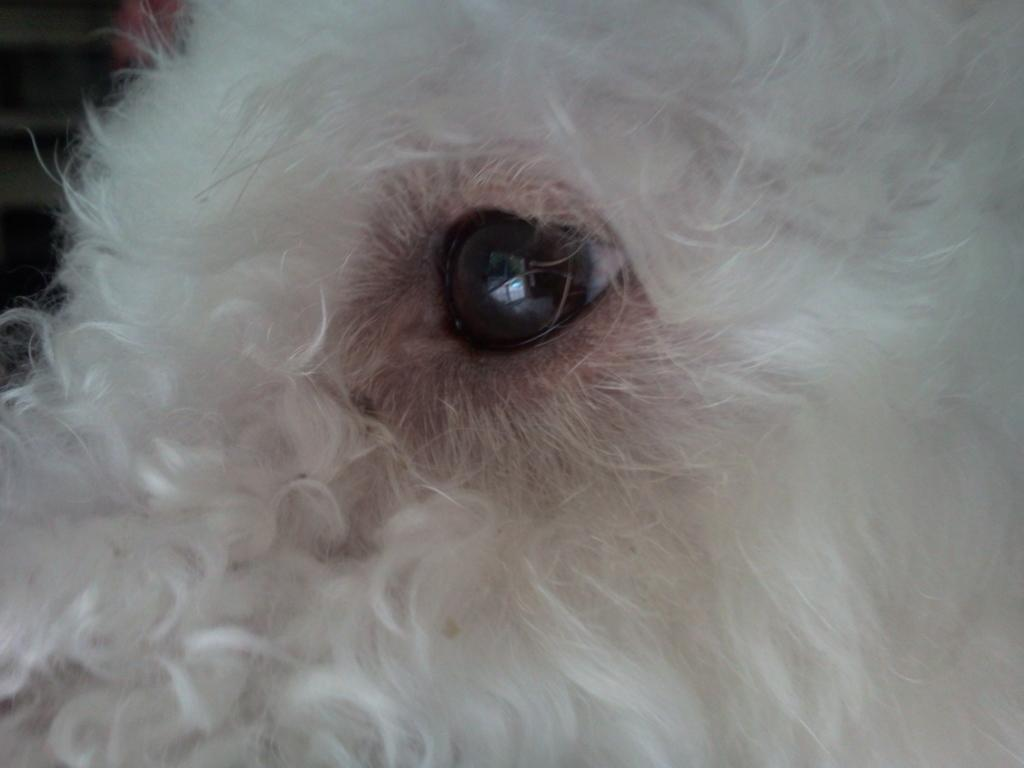What is the main subject of the image? The main subject of the image is a dog's eye. Can you describe the eye in the image? The image shows a dog's eye, which is a round, brown eye with a dark pupil. How many sisters are present in the image? There are no sisters present in the image; it only shows a dog's eye. What type of box can be seen in the image? There is no box present in the image; it only shows a dog's eye. 